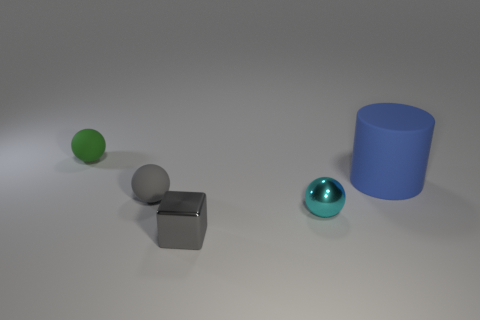Subtract all tiny metal balls. How many balls are left? 2 Subtract all balls. How many objects are left? 2 Add 5 small green rubber spheres. How many objects exist? 10 Subtract all cyan metallic balls. Subtract all spheres. How many objects are left? 1 Add 2 matte cylinders. How many matte cylinders are left? 3 Add 3 tiny yellow metal things. How many tiny yellow metal things exist? 3 Subtract 0 gray cylinders. How many objects are left? 5 